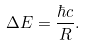Convert formula to latex. <formula><loc_0><loc_0><loc_500><loc_500>\Delta E = \frac { \hbar { c } } { R } .</formula> 